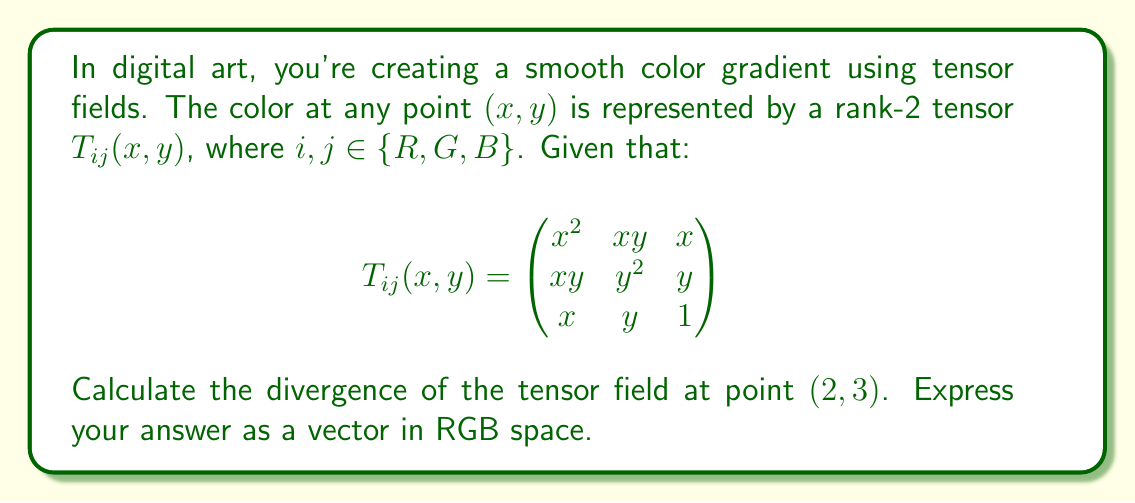Show me your answer to this math problem. To solve this problem, we'll follow these steps:

1) The divergence of a rank-2 tensor field in 2D is given by:

   $$\text{div}(T) = \frac{\partial T_{iR}}{\partial x} + \frac{\partial T_{iG}}{\partial y}$$

   where $i \in \{R,G,B\}$

2) Let's calculate each component:

   For $i = R$:
   $$\frac{\partial T_{RR}}{\partial x} = \frac{\partial (x^2)}{\partial x} = 2x$$
   $$\frac{\partial T_{RG}}{\partial y} = \frac{\partial (xy)}{\partial y} = x$$

   For $i = G$:
   $$\frac{\partial T_{GR}}{\partial x} = \frac{\partial (xy)}{\partial x} = y$$
   $$\frac{\partial T_{GG}}{\partial y} = \frac{\partial (y^2)}{\partial y} = 2y$$

   For $i = B$:
   $$\frac{\partial T_{BR}}{\partial x} = \frac{\partial x}{\partial x} = 1$$
   $$\frac{\partial T_{BG}}{\partial y} = \frac{\partial y}{\partial y} = 1$$

3) Now, we sum these partial derivatives for each component:

   $R: 2x + x = 3x$
   $G: y + 2y = 3y$
   $B: 1 + 1 = 2$

4) Evaluate at point $(2,3)$:

   $R: 3(2) = 6$
   $G: 3(3) = 9$
   $B: 2$

Therefore, the divergence of the tensor field at $(2,3)$ is $(6,9,2)$ in RGB space.
Answer: $(6,9,2)$ 